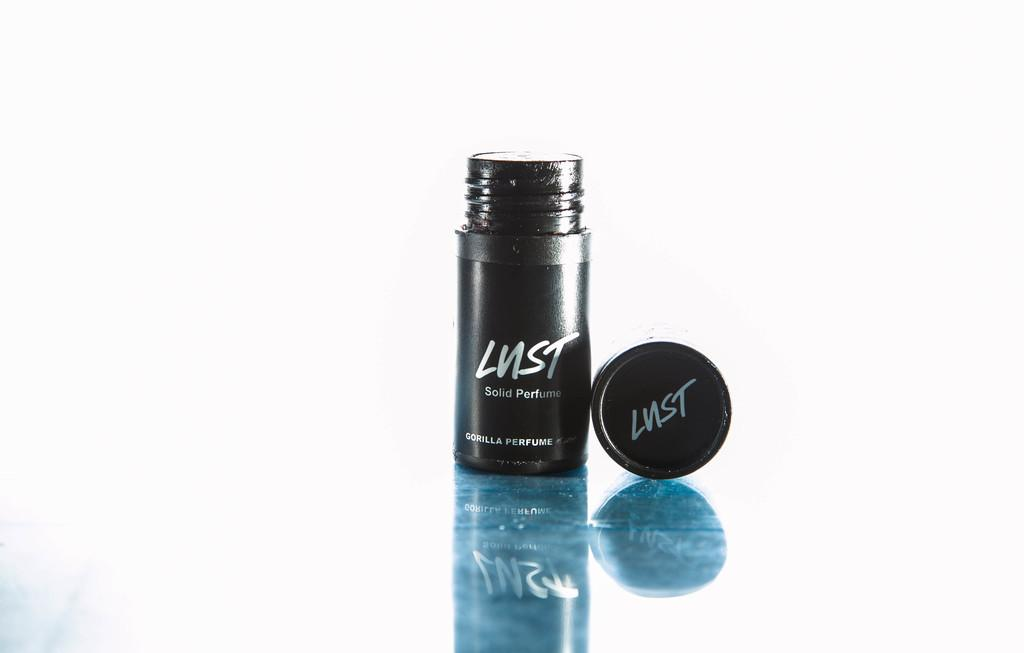<image>
Offer a succinct explanation of the picture presented. Bottle of Lust in front of a white background. 